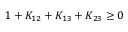<formula> <loc_0><loc_0><loc_500><loc_500>1 + K _ { 1 2 } + K _ { 1 3 } + K _ { 2 3 } \geq 0</formula> 